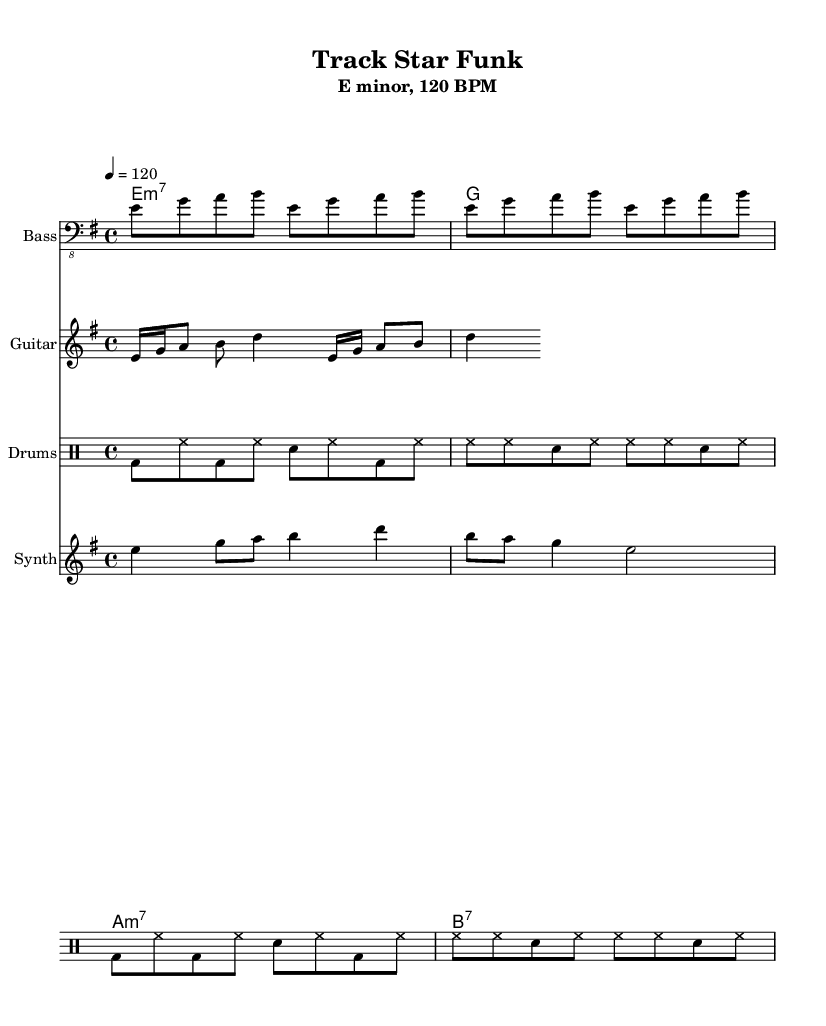What is the key signature of this music? The key signature is E minor, which has one sharp (F#). It is identified by the notation at the beginning of the score.
Answer: E minor What is the time signature? The time signature is found next to the key signature and indicates how many beats are in each measure. In this case, it is 4/4, meaning there are four beats per measure.
Answer: 4/4 What is the tempo marking? The tempo marking is indicated in the score as "120 BPM", which tells the performers to play at a speed of 120 beats per minute. This is a common fast tempo for Funk music.
Answer: 120 BPM How many measures are in the bass line? The bass line consists of repeated motifs, specifically stated as 'repeat unfold 4', indicating that the motif plays over four measures.
Answer: 4 measures What is the rhythm of the drums? The drum pattern is indicated using standard drum notation with the bass drum, hi-hat, and snare drum sections specified. By observing the repeated patterns, one can see that the rhythm features alternating strokes with specific placements in the measures described.
Answer: Funky What kind of chords are used in this piece? The chord progression includes minor and dominant seventh chords typical of Funk. The chord names specify E minor 7, A minor 7, and B7, reflecting the typical harmonic structure in this genre.
Answer: Minor and dominant seventh How does the guitar riff contribute to the Funk style? The guitar riff utilizes syncopation and rapid alternation between notes, creating a funky feel. The use of 16th notes along with rests also emphasizes rhythmic playfulness, characteristic of Funk music.
Answer: Syncopated 